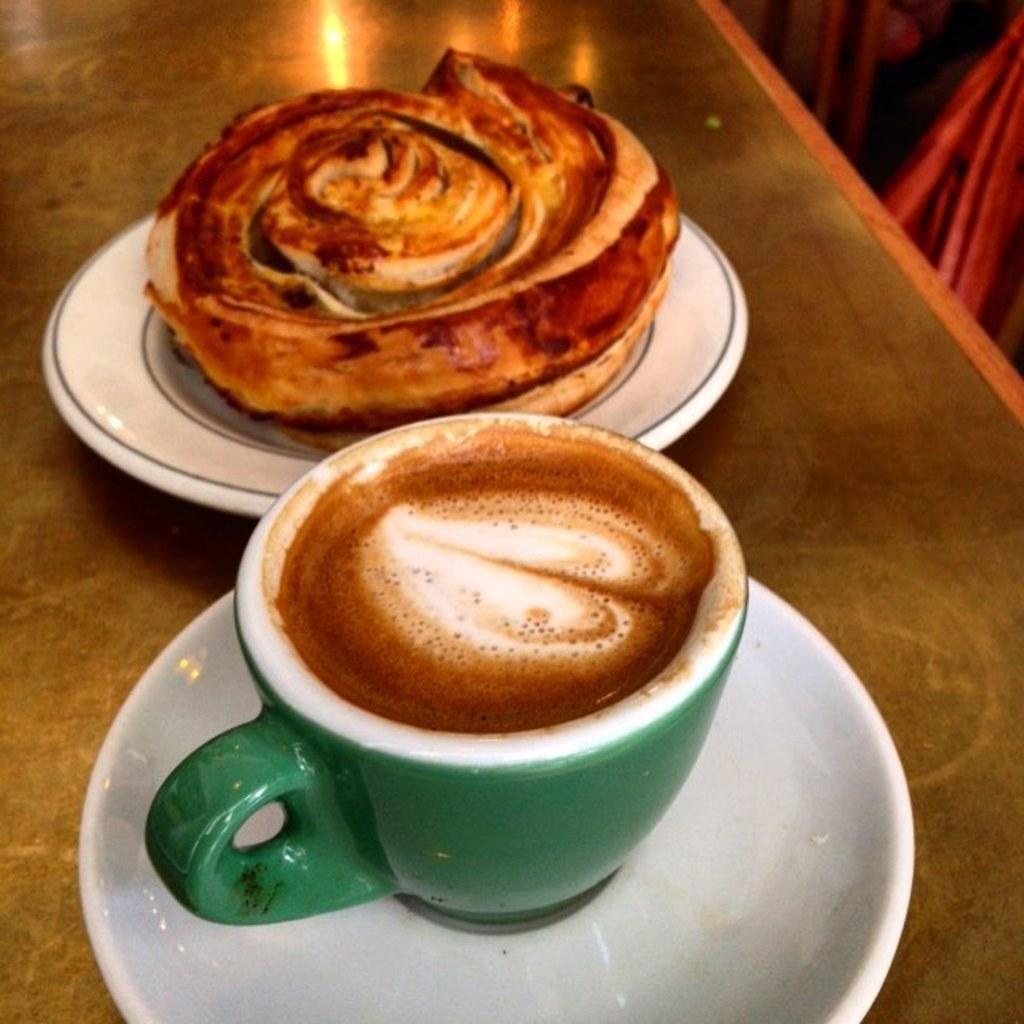Could you give a brief overview of what you see in this image? In this image we can see a cup of coffee. There is food item is placed on the plate. A cup of coffee cup and plate is placed on the table. 